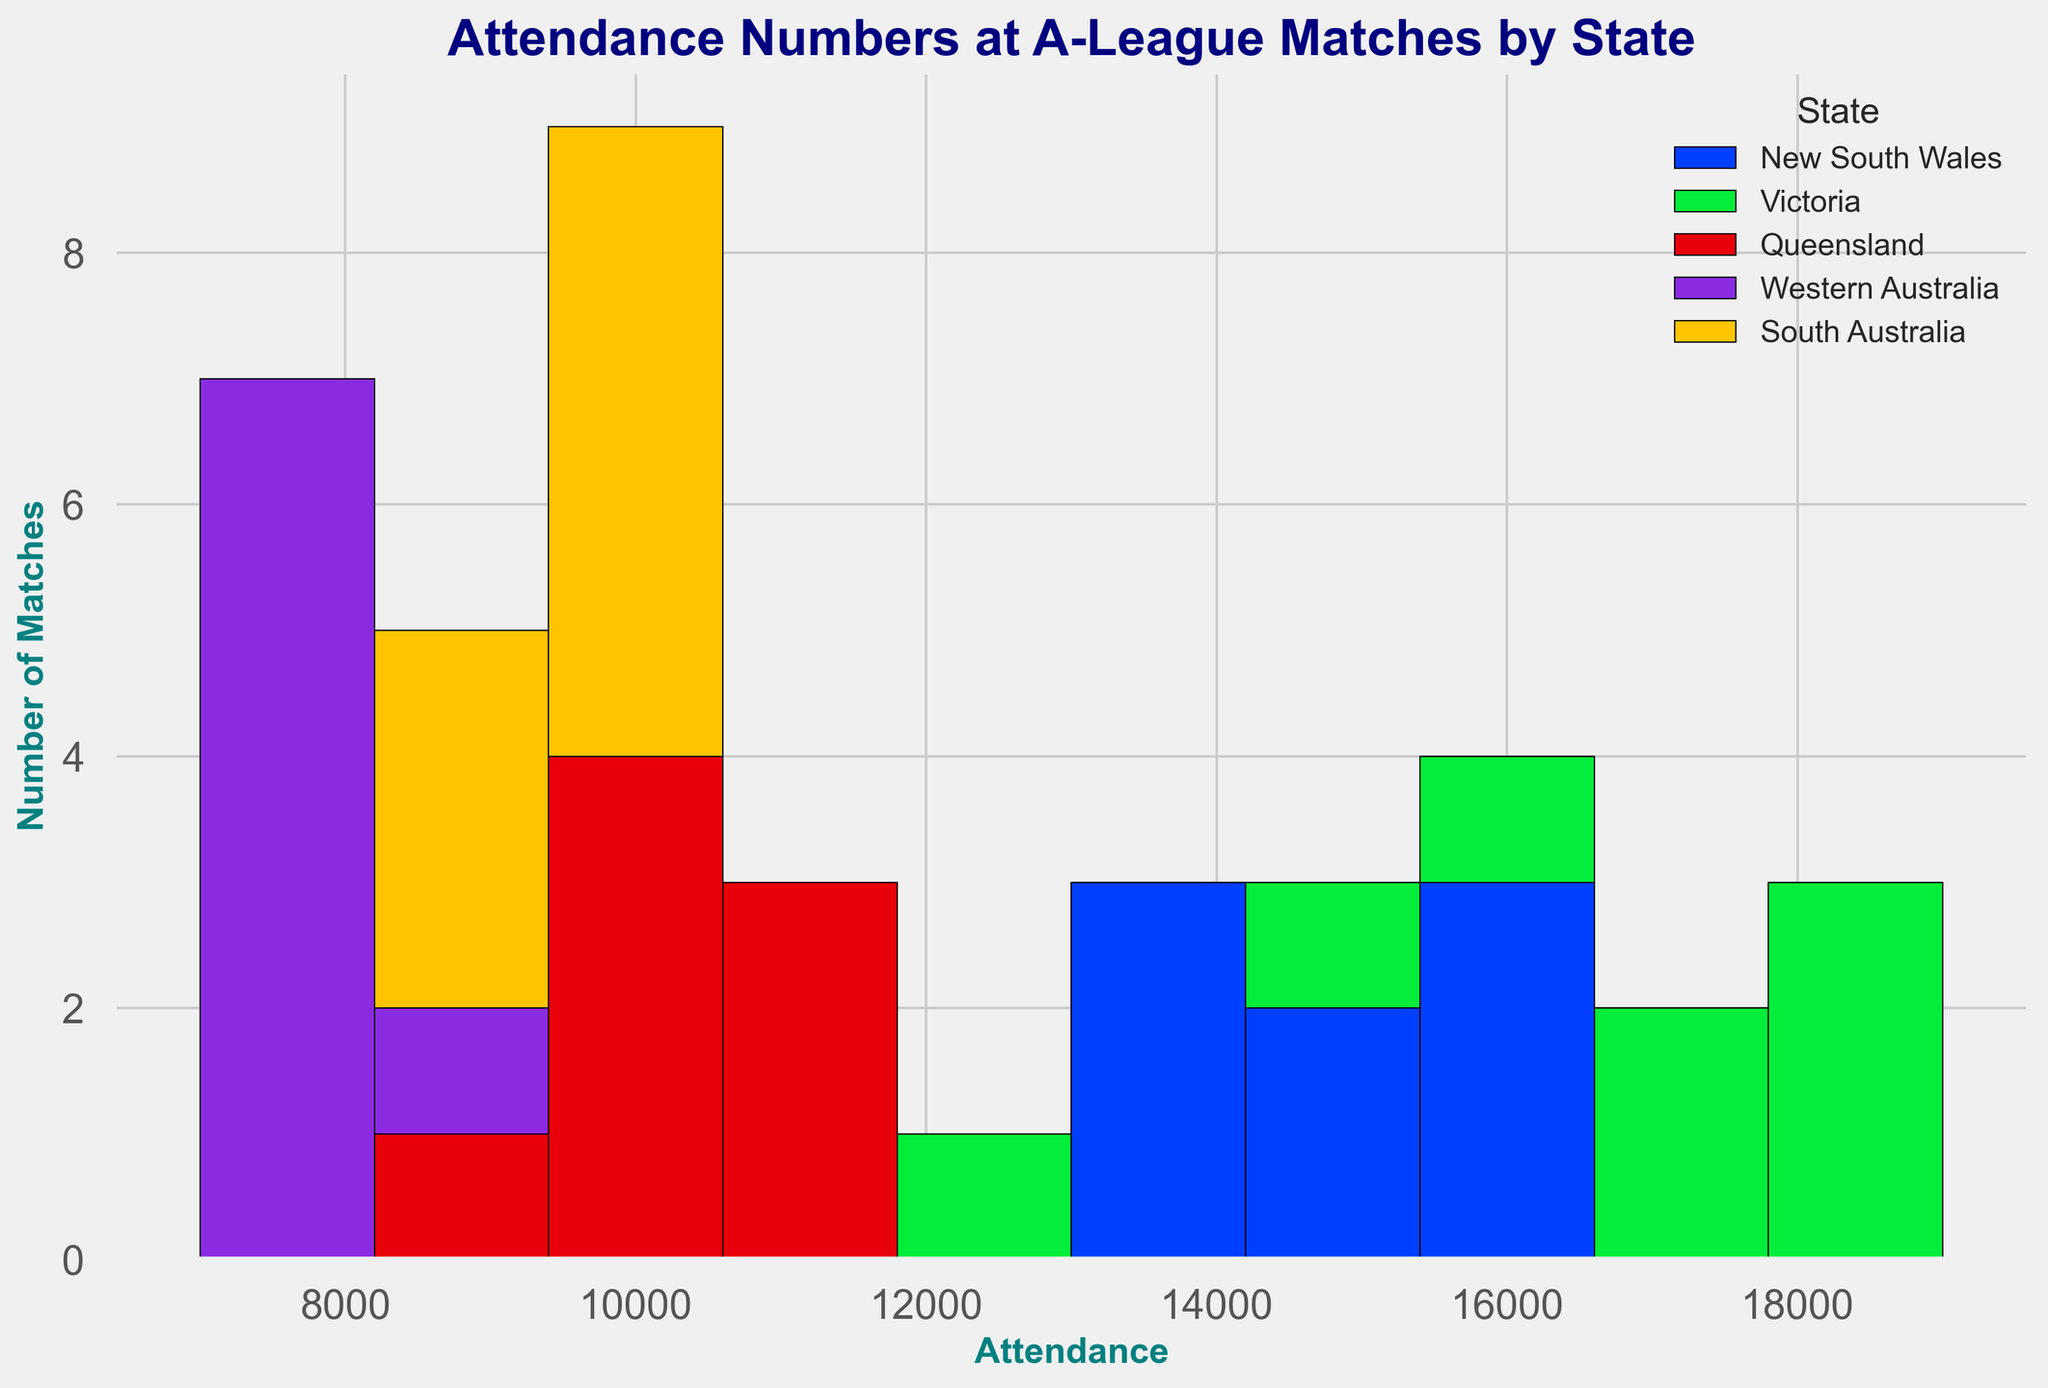Which state has the highest attendance at A-League matches? By observing the histogram, look for the block with the highest attendance value. The highest block represents Victoria with 19000 attendees.
Answer: Victoria How does the average attendance in New South Wales compare to that in Victoria? Calculate the average attendance for both states and compare. Average for New South Wales requires summing all attendance numbers for NSW and dividing by the count of matches, similarly for Victoria. Compare the averages of the two states.
Answer: Victoria has a higher average attendance Which state has the widest range in attendance numbers? Identify the range of attendance numbers for each state by looking for the highest and lowest values in the histogram. Compare these ranges.
Answer: New South Wales What is the most common attendance range for Western Australia? Look for the most frequently occurring attendance range for Western Australia in the histogram. This is the range that has the highest block in the histogram.
Answer: 7000-8000 Compare the total number of matches held in Queensland and South Australia. Count the number of bars for Queensland and South Australia in the histogram. Each bar represents a match. If bars are stacked, add them up separately for each state.
Answer: Queensland and South Australia have a similar number of matches Which state has the least number of matches with attendance over 15000? Look at blocks representing matches with attendance over 15000 and count how many there are for each state. Identify the state with the fewest blocks over that attendance.
Answer: Queensland What is the sum of all attendances in South Australia? Add up all the attendance numbers for South Australia matches visible in the histogram.
Answer: 47000 Has New South Wales held more or fewer matches than Victoria? Compare the number of bars representing matches for both New South Wales and Victoria in the histogram. Each bar signifies one match.
Answer: Fewer Which state has the most balanced attendance distribution? Examine the histograms for each state. The state with the histogram having bars of more similar heights represents a balanced distribution.
Answer: South Australia What is the difference in the highest attendance between New South Wales and Western Australia? Find the highest attendance bar for New South Wales and for Western Australia in the histogram, then subtract the latter from the former to get the difference.
Answer: 8800 